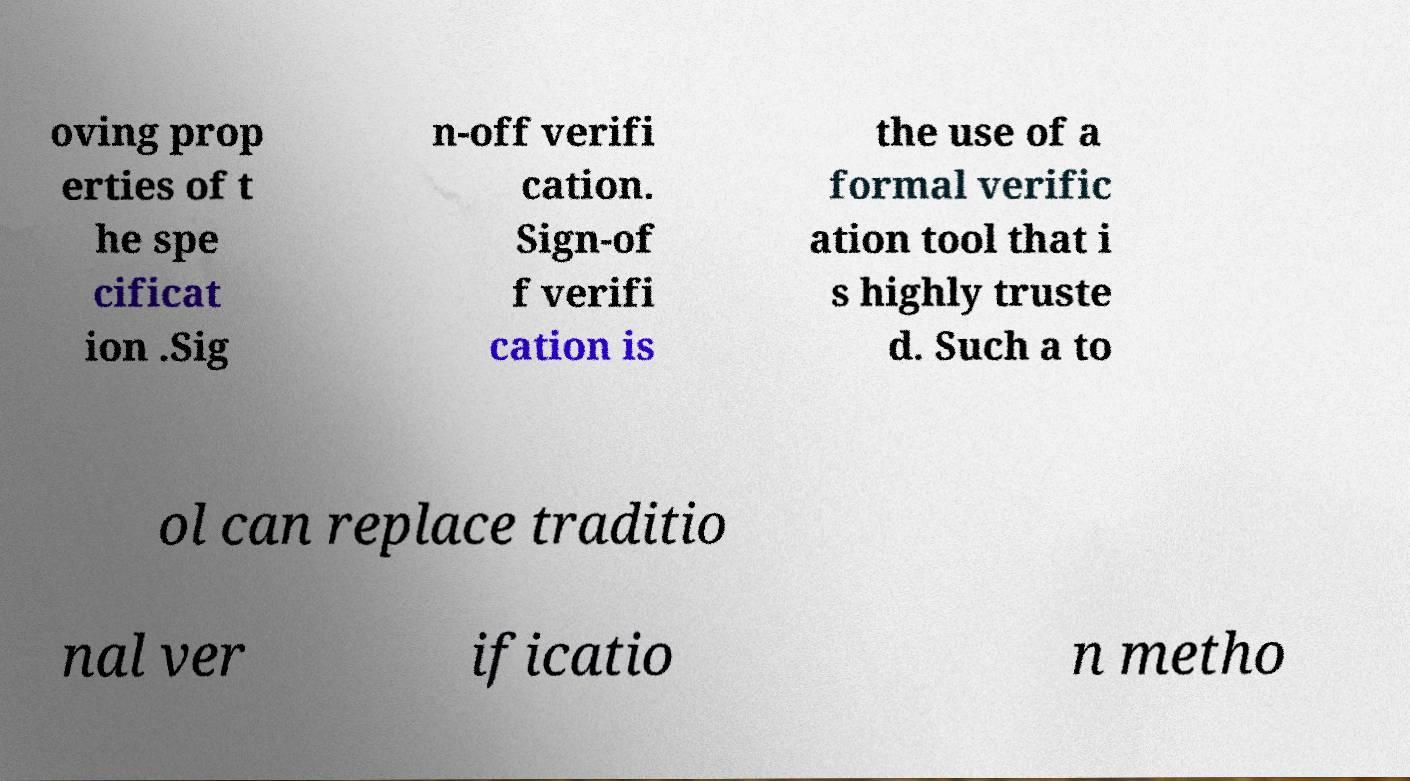There's text embedded in this image that I need extracted. Can you transcribe it verbatim? oving prop erties of t he spe cificat ion .Sig n-off verifi cation. Sign-of f verifi cation is the use of a formal verific ation tool that i s highly truste d. Such a to ol can replace traditio nal ver ificatio n metho 